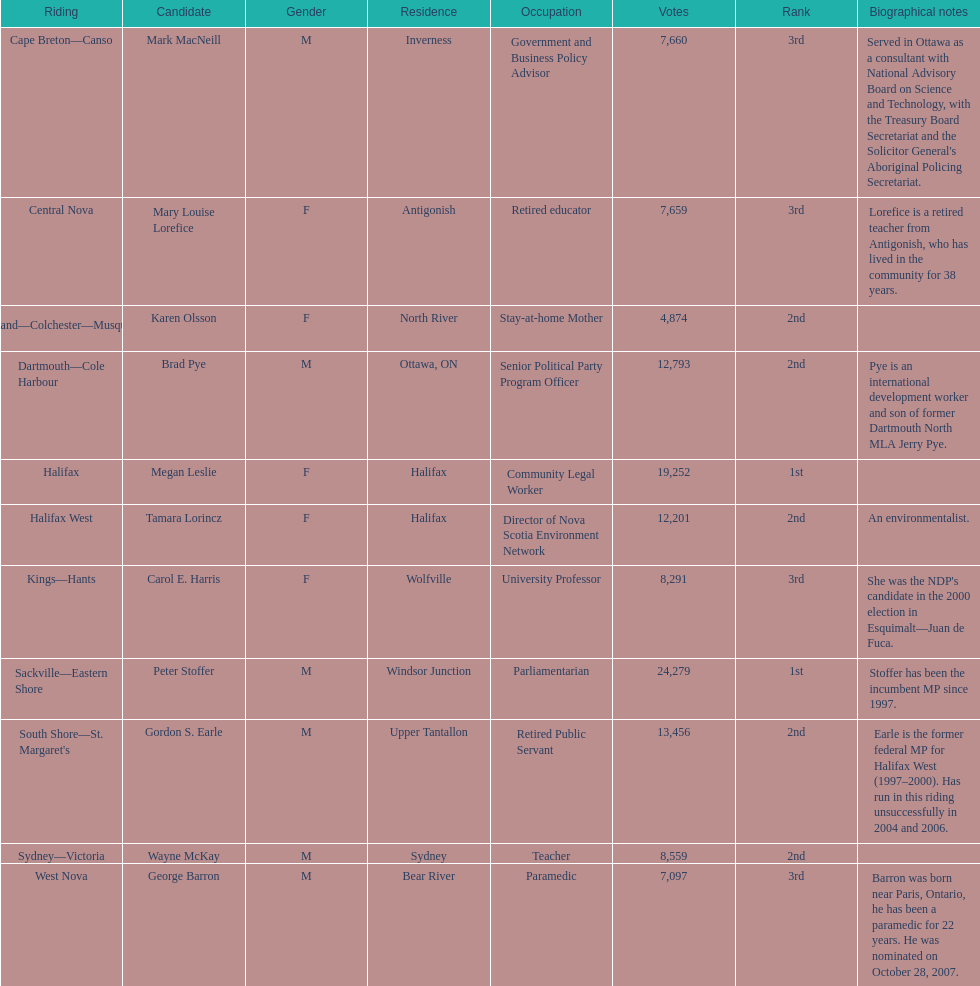Tell me the total number of votes the female candidates got. 52,277. 